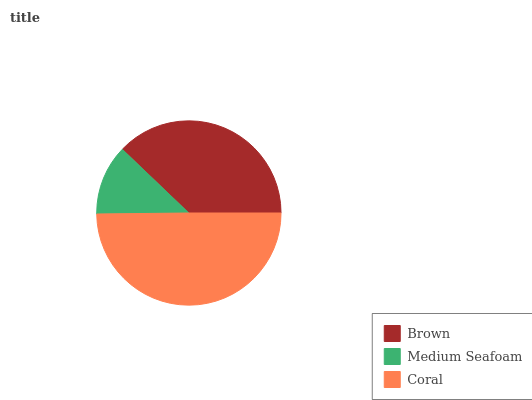Is Medium Seafoam the minimum?
Answer yes or no. Yes. Is Coral the maximum?
Answer yes or no. Yes. Is Coral the minimum?
Answer yes or no. No. Is Medium Seafoam the maximum?
Answer yes or no. No. Is Coral greater than Medium Seafoam?
Answer yes or no. Yes. Is Medium Seafoam less than Coral?
Answer yes or no. Yes. Is Medium Seafoam greater than Coral?
Answer yes or no. No. Is Coral less than Medium Seafoam?
Answer yes or no. No. Is Brown the high median?
Answer yes or no. Yes. Is Brown the low median?
Answer yes or no. Yes. Is Medium Seafoam the high median?
Answer yes or no. No. Is Medium Seafoam the low median?
Answer yes or no. No. 